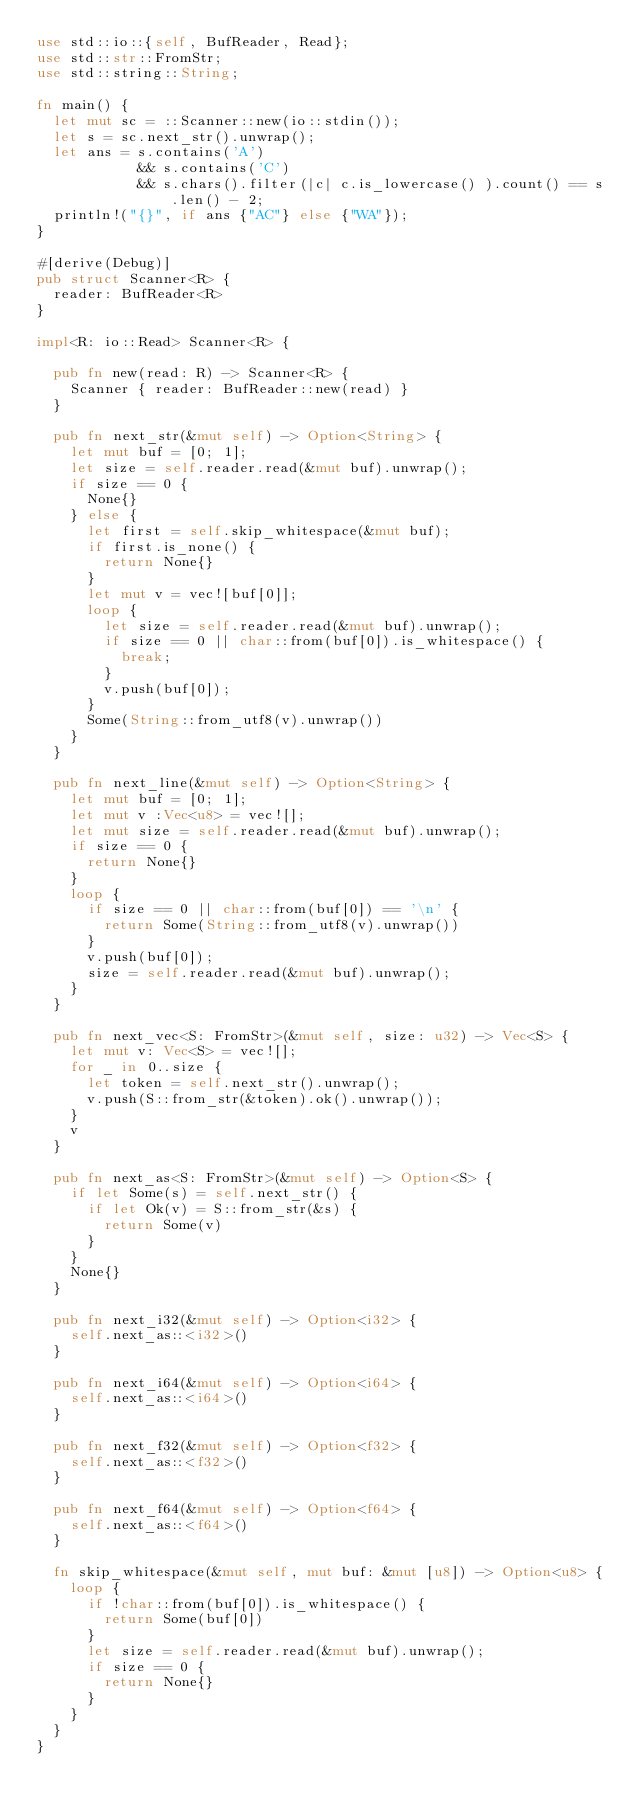Convert code to text. <code><loc_0><loc_0><loc_500><loc_500><_Rust_>use std::io::{self, BufReader, Read};
use std::str::FromStr;
use std::string::String;

fn main() {
	let mut sc = ::Scanner::new(io::stdin());
	let s = sc.next_str().unwrap();
	let ans = s.contains('A')
	          && s.contains('C')
	          && s.chars().filter(|c| c.is_lowercase() ).count() == s.len() - 2;
	println!("{}", if ans {"AC"} else {"WA"});
}

#[derive(Debug)]
pub struct Scanner<R> {
	reader: BufReader<R>
}

impl<R: io::Read> Scanner<R> {
	
	pub fn new(read: R) -> Scanner<R> {
		Scanner { reader: BufReader::new(read) }
	}

	pub fn next_str(&mut self) -> Option<String> {
		let mut buf = [0; 1];
		let size = self.reader.read(&mut buf).unwrap();
		if size == 0 {
			None{}
		} else {
			let first = self.skip_whitespace(&mut buf);
			if first.is_none() {
				return None{}
			}
			let mut v = vec![buf[0]];
			loop {
				let size = self.reader.read(&mut buf).unwrap();
				if size == 0 || char::from(buf[0]).is_whitespace() {
					break;
				}
				v.push(buf[0]);
			}
			Some(String::from_utf8(v).unwrap())
		}
	}

	pub fn next_line(&mut self) -> Option<String> {
		let mut buf = [0; 1];
		let mut v :Vec<u8> = vec![];
		let mut size = self.reader.read(&mut buf).unwrap();
		if size == 0 {
			return None{}
		}
		loop {
			if size == 0 || char::from(buf[0]) == '\n' {
				return Some(String::from_utf8(v).unwrap())
			}
			v.push(buf[0]);
			size = self.reader.read(&mut buf).unwrap();
		}
	}

	pub fn next_vec<S: FromStr>(&mut self, size: u32) -> Vec<S> {
		let mut v: Vec<S> = vec![];
		for _ in 0..size {
			let token = self.next_str().unwrap();
			v.push(S::from_str(&token).ok().unwrap());
		}
		v
	}

	pub fn next_as<S: FromStr>(&mut self) -> Option<S> {
		if let Some(s) = self.next_str() {
			if let Ok(v) = S::from_str(&s) {
				return Some(v)
			}
		}
		None{}
	}

	pub fn next_i32(&mut self) -> Option<i32> {
		self.next_as::<i32>()
	}

	pub fn next_i64(&mut self) -> Option<i64> {
		self.next_as::<i64>()
	}

	pub fn next_f32(&mut self) -> Option<f32> {
		self.next_as::<f32>()
	}

	pub fn next_f64(&mut self) -> Option<f64> {
		self.next_as::<f64>()
	}

	fn skip_whitespace(&mut self, mut buf: &mut [u8]) -> Option<u8> {
		loop {
			if !char::from(buf[0]).is_whitespace() {
				return Some(buf[0])
			}
			let size = self.reader.read(&mut buf).unwrap();
			if size == 0 {
				return None{}
			}
		}
	}
}
</code> 